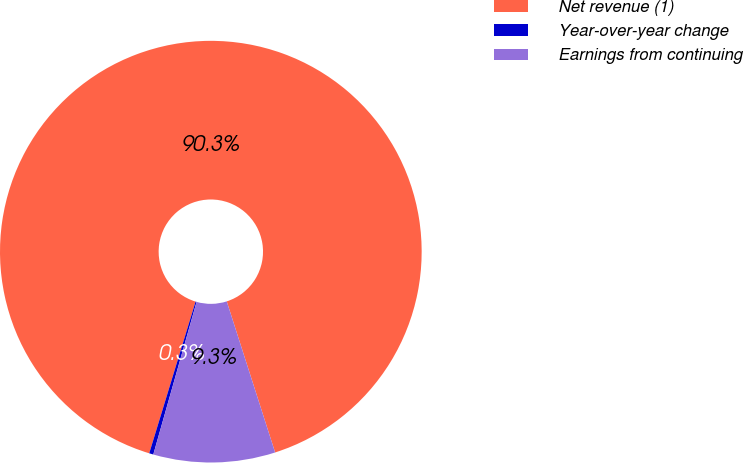Convert chart. <chart><loc_0><loc_0><loc_500><loc_500><pie_chart><fcel>Net revenue (1)<fcel>Year-over-year change<fcel>Earnings from continuing<nl><fcel>90.35%<fcel>0.32%<fcel>9.33%<nl></chart> 